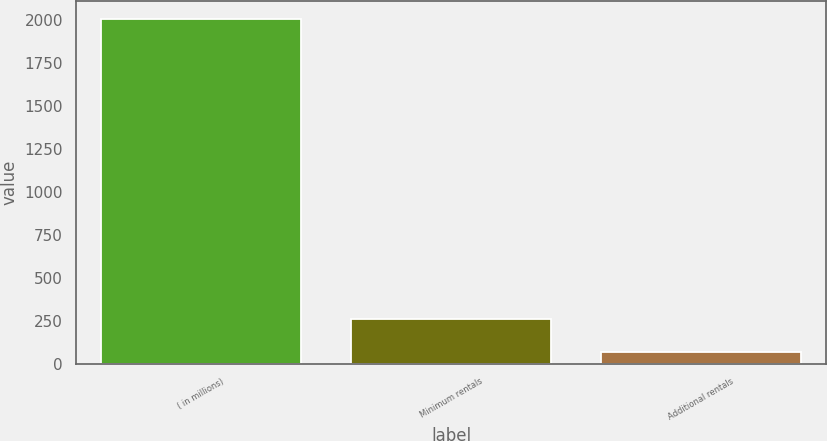<chart> <loc_0><loc_0><loc_500><loc_500><bar_chart><fcel>( in millions)<fcel>Minimum rentals<fcel>Additional rentals<nl><fcel>2010<fcel>261.3<fcel>67<nl></chart> 